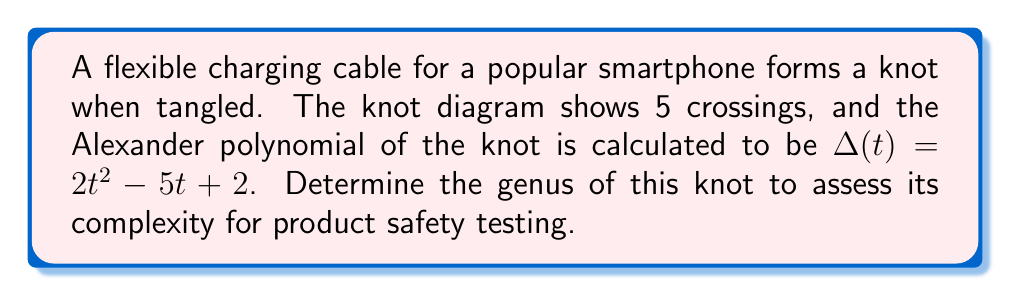Provide a solution to this math problem. To find the genus of the knot, we'll follow these steps:

1. Recall the relationship between the genus $g$, the degree of the Alexander polynomial $d$, and the number of crossings $n$:

   $$2g \leq d \leq n - 1$$

2. Identify the degree of the Alexander polynomial:
   $\Delta(t) = 2t^2 - 5t + 2$
   The degree $d = 2$

3. We know the number of crossings $n = 5$

4. Substitute these values into the inequality:
   $$2g \leq 2 \leq 5 - 1 = 4$$

5. Simplify:
   $$2g \leq 2 \leq 4$$

6. Focus on the left side of the inequality:
   $$2g \leq 2$$

7. Solve for $g$:
   $$g \leq 1$$

8. Since $g$ must be a non-negative integer, and it's less than or equal to 1, the only possible values are 0 or 1.

9. A genus of 0 would indicate an unknot, which is inconsistent with the given Alexander polynomial. Therefore, the genus must be 1.

This genus value indicates a moderately complex knot, which could be relevant for assessing the tendency of the cable to tangle and potentially impact its durability or user experience.
Answer: $g = 1$ 